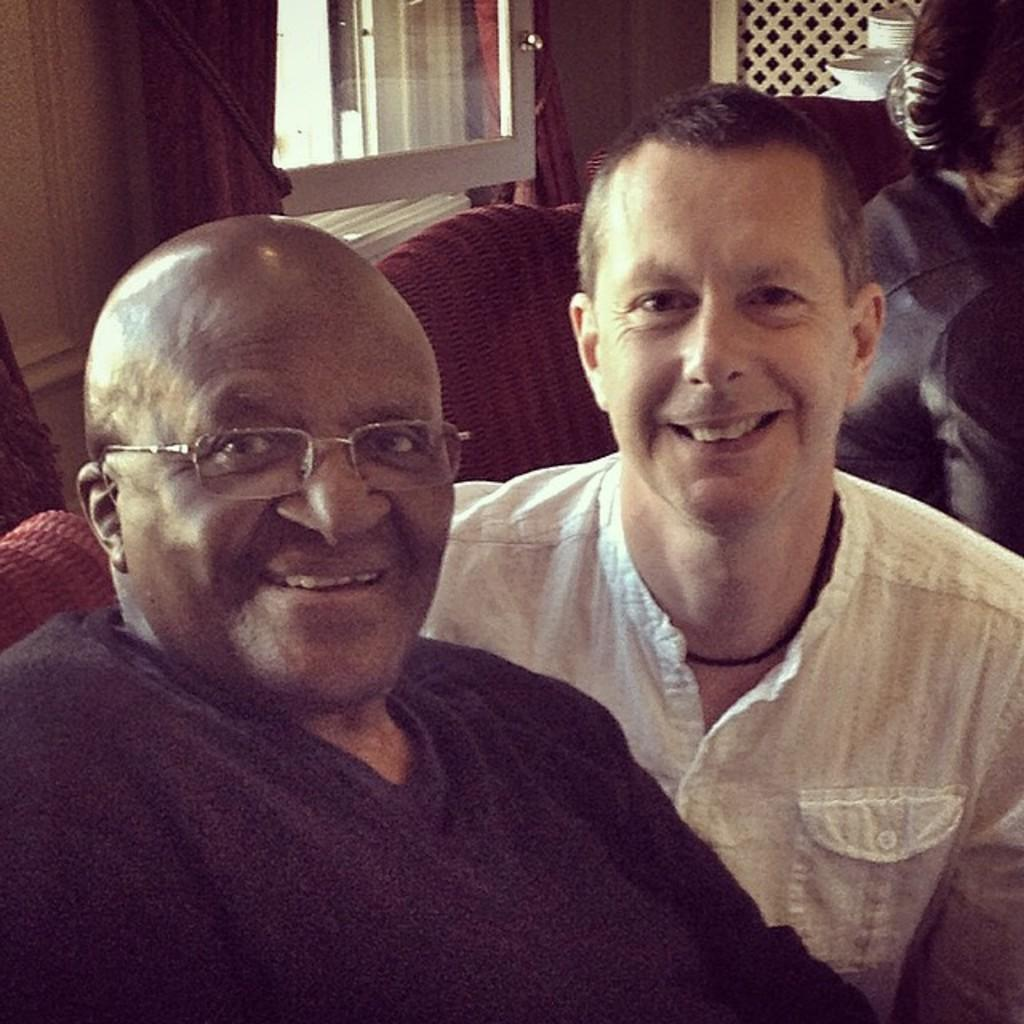How many people are present in the image? There are two people in the image. What is the facial expression of the people in the image? The two people are smiling. What can be seen in the background of the image? There is a person, a wall, a window, chairs, and some objects in the background of the image. What type of legal advice is the person in the background providing in the image? There is no indication in the image that a lawyer or any legal advice is present. 